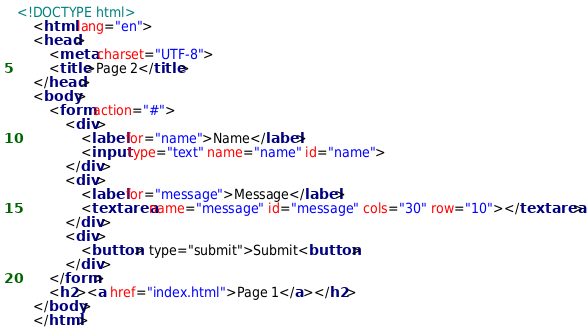<code> <loc_0><loc_0><loc_500><loc_500><_HTML_><!DOCTYPE html>
    <html lang="en">
    <head>
        <meta charset="UTF-8">
        <title>Page 2</title>
    </head>
    <body>
        <form action="#">
            <div>
                <label for="name">Name</label>
                <input type="text" name="name" id="name">
            </div>
            <div>
                <label for="message">Message</label>
                <textarea name="message" id="message" cols="30" row="10"></textarea>
            </div>
            <div>
                <button> type="submit">Submit<button>
            </div>
        </form>
        <h2><a href="index.html">Page 1</a></h2>
    </body>
    </html>
</code> 